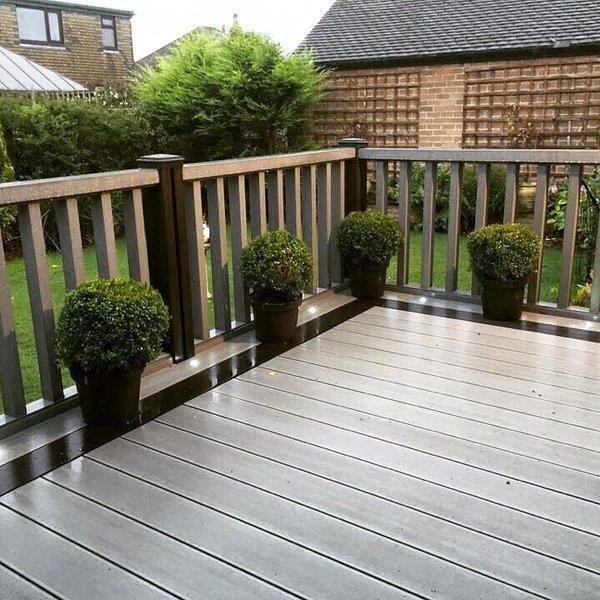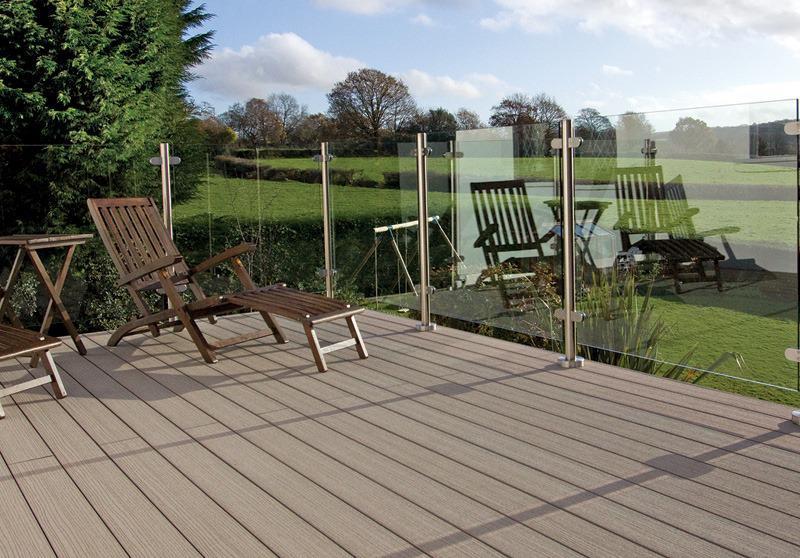The first image is the image on the left, the second image is the image on the right. Assess this claim about the two images: "There are two chairs and one wooden slotted table on a patio that is enclosed  with glass panels.". Correct or not? Answer yes or no. Yes. The first image is the image on the left, the second image is the image on the right. Assess this claim about the two images: "In each image, a glass-paneled balcony overlooks an area of green grass, and one of the balconies pictured has a top rail on the glass panels but the other does not.". Correct or not? Answer yes or no. No. 